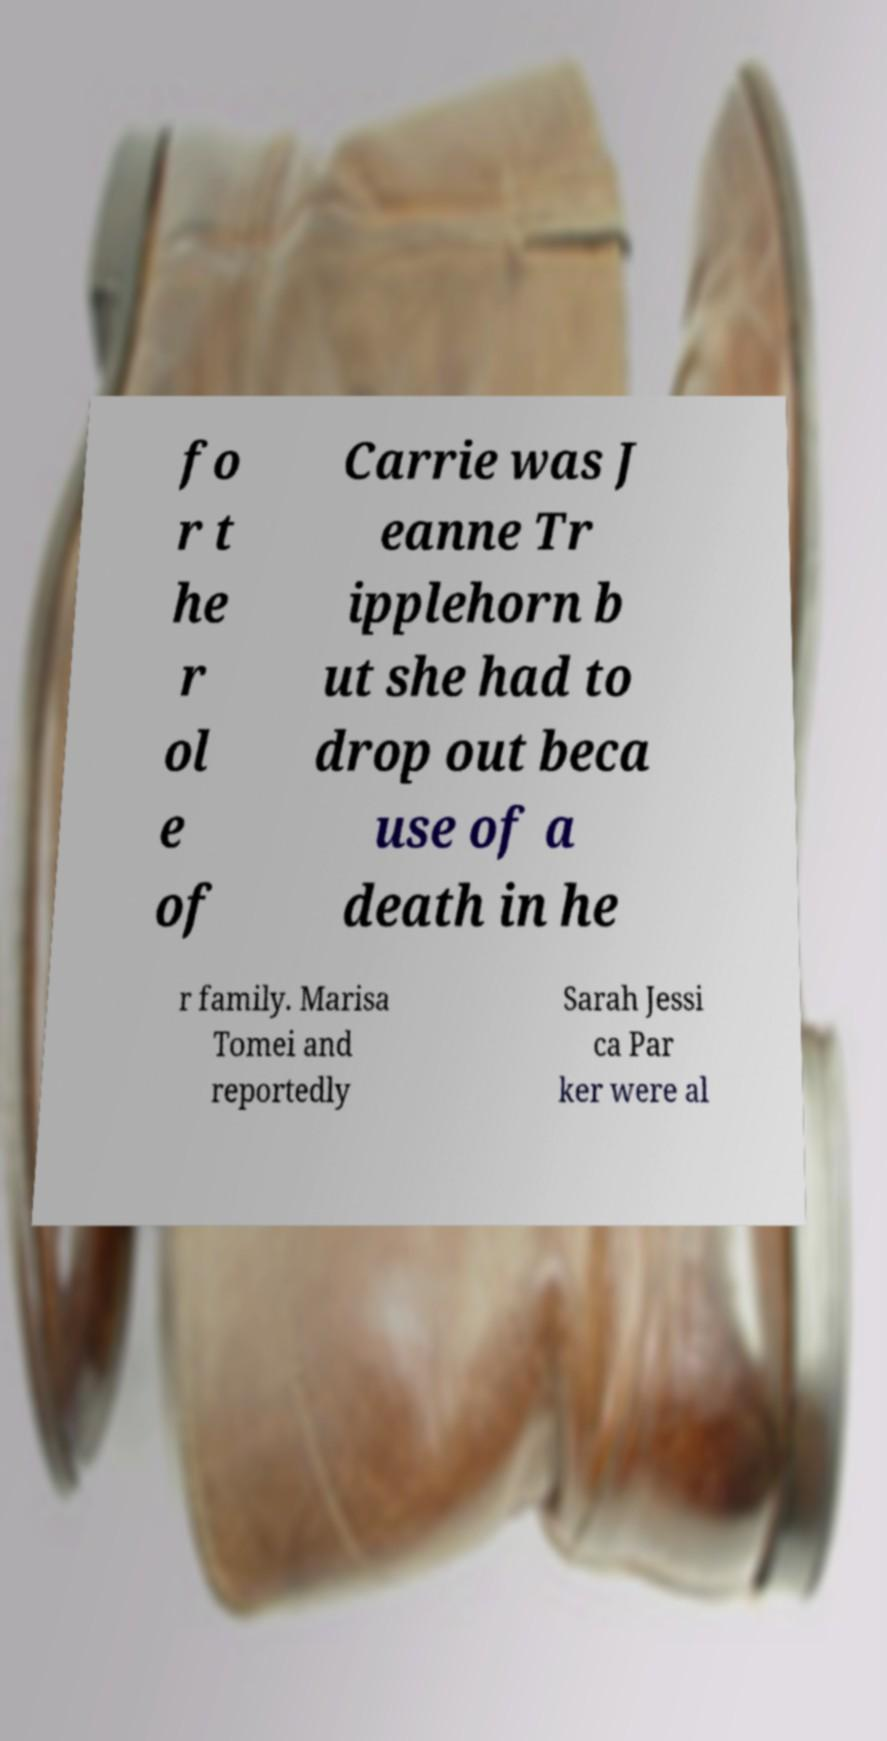Can you read and provide the text displayed in the image?This photo seems to have some interesting text. Can you extract and type it out for me? fo r t he r ol e of Carrie was J eanne Tr ipplehorn b ut she had to drop out beca use of a death in he r family. Marisa Tomei and reportedly Sarah Jessi ca Par ker were al 